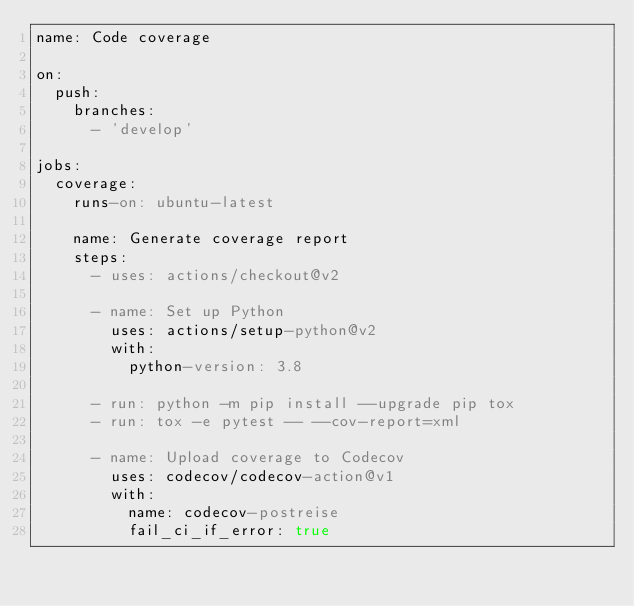Convert code to text. <code><loc_0><loc_0><loc_500><loc_500><_YAML_>name: Code coverage

on:
  push:
    branches:
      - 'develop'

jobs:
  coverage:
    runs-on: ubuntu-latest

    name: Generate coverage report
    steps:
      - uses: actions/checkout@v2

      - name: Set up Python
        uses: actions/setup-python@v2
        with:
          python-version: 3.8

      - run: python -m pip install --upgrade pip tox
      - run: tox -e pytest -- --cov-report=xml

      - name: Upload coverage to Codecov
        uses: codecov/codecov-action@v1
        with:
          name: codecov-postreise
          fail_ci_if_error: true
</code> 